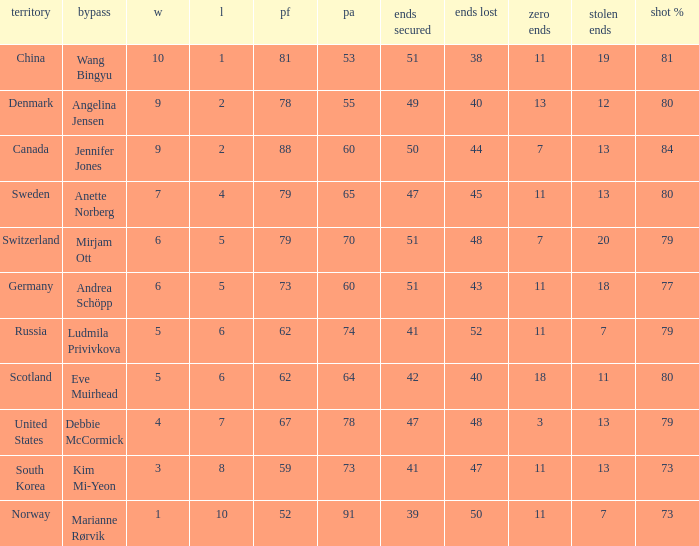When the country was Scotland, how many ends were won? 1.0. 